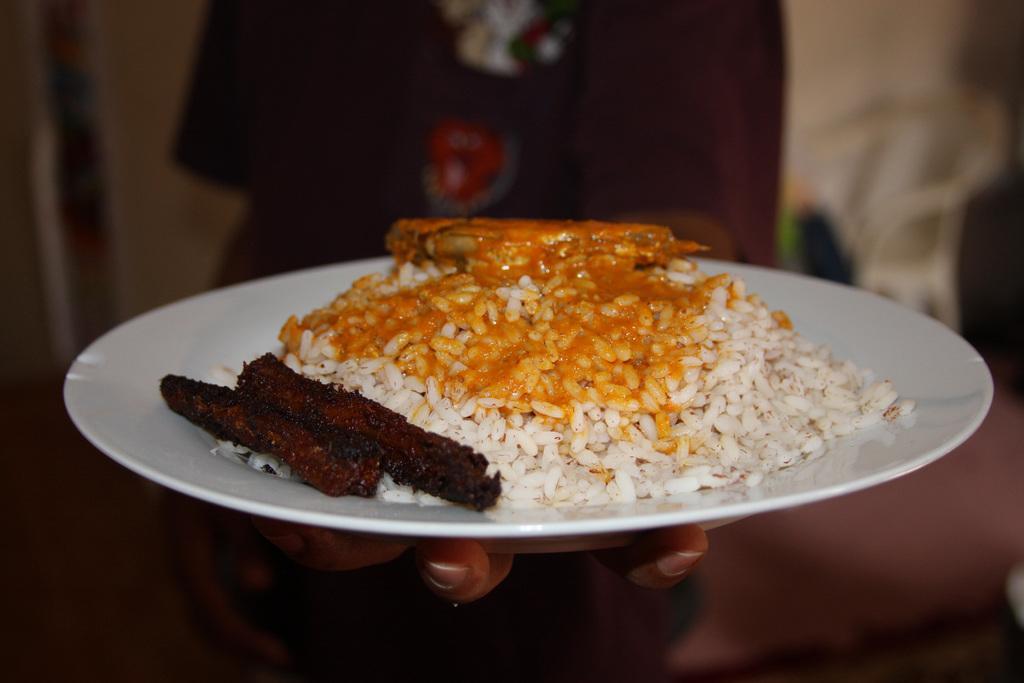Could you give a brief overview of what you see in this image? In this picture we can see a person is holding a plate and on the plate there are some food items. Behind the person, there is a chair and the blurred background. 